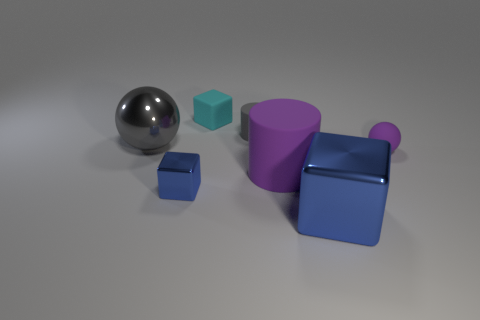Subtract 1 cubes. How many cubes are left? 2 Add 3 small brown metal cubes. How many objects exist? 10 Subtract all blocks. How many objects are left? 4 Subtract 1 purple spheres. How many objects are left? 6 Subtract all tiny cylinders. Subtract all shiny balls. How many objects are left? 5 Add 1 tiny matte cubes. How many tiny matte cubes are left? 2 Add 5 tiny yellow objects. How many tiny yellow objects exist? 5 